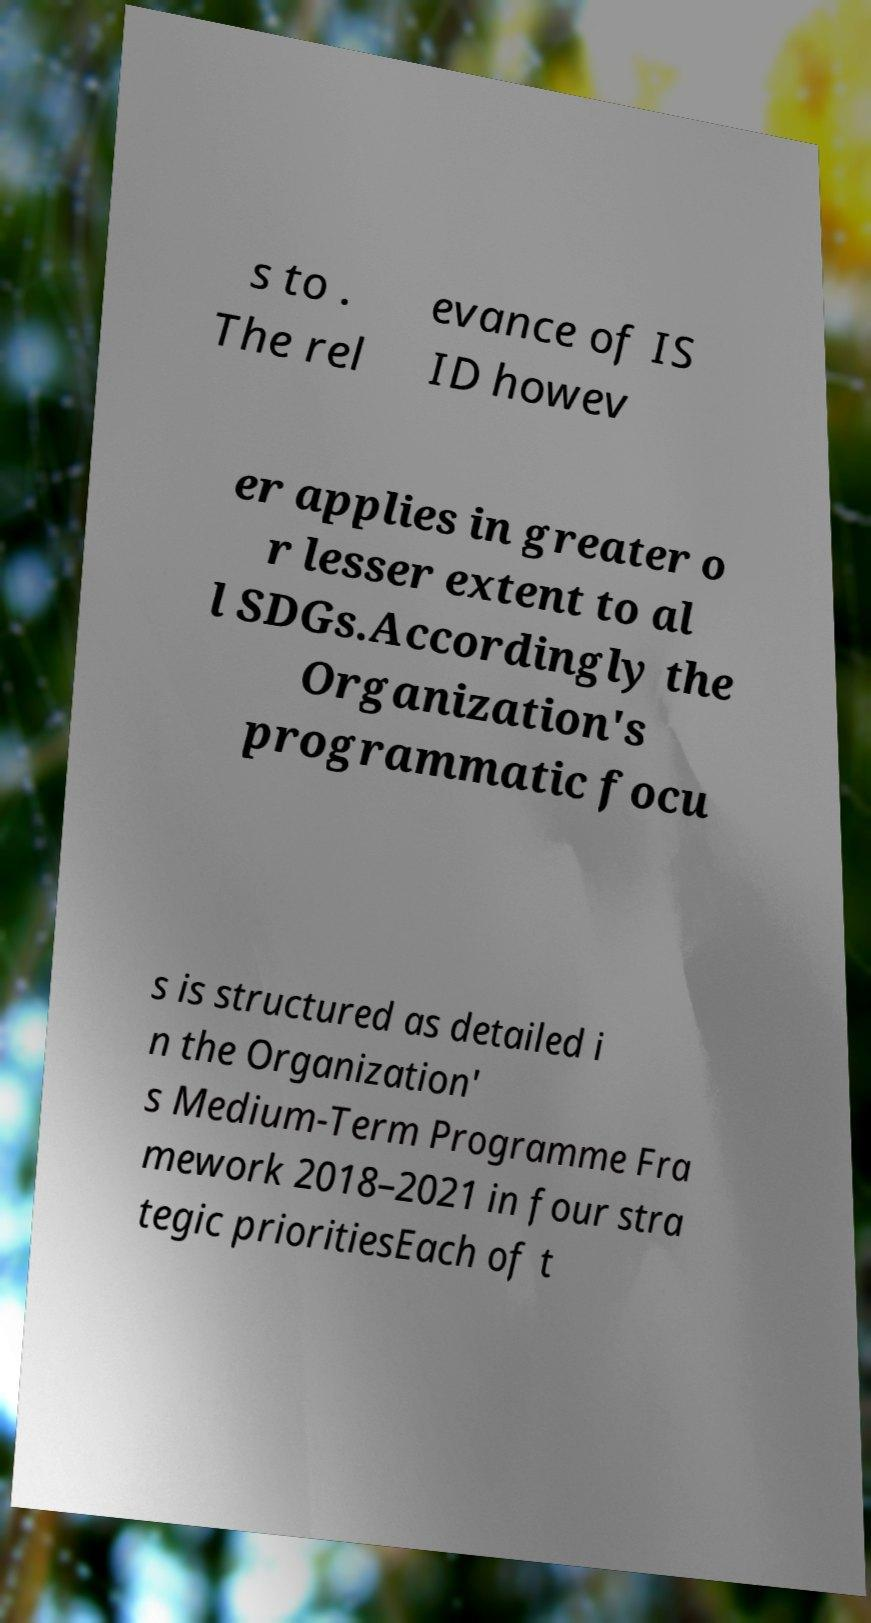What messages or text are displayed in this image? I need them in a readable, typed format. s to . The rel evance of IS ID howev er applies in greater o r lesser extent to al l SDGs.Accordingly the Organization's programmatic focu s is structured as detailed i n the Organization' s Medium-Term Programme Fra mework 2018–2021 in four stra tegic prioritiesEach of t 